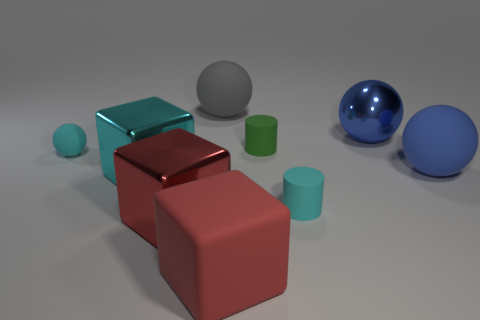Subtract all big gray matte spheres. How many spheres are left? 3 Subtract all gray spheres. How many spheres are left? 3 Subtract 1 spheres. How many spheres are left? 3 Subtract all red spheres. Subtract all brown blocks. How many spheres are left? 4 Subtract all cylinders. How many objects are left? 7 Add 4 small blue rubber things. How many small blue rubber things exist? 4 Subtract 0 blue cylinders. How many objects are left? 9 Subtract all small green metal cylinders. Subtract all tiny objects. How many objects are left? 6 Add 4 blue matte things. How many blue matte things are left? 5 